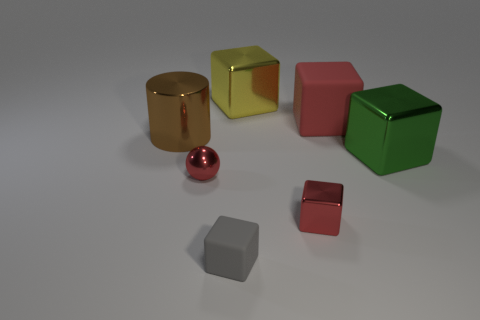Describe the colors visible in the scene. Certainly! The scene displays a rich assortment of colors: there's a golden cylinder, a yellow cube, a red cube, a green cube, a small red sphere, and two gray objects, one a darker shade than the other. 